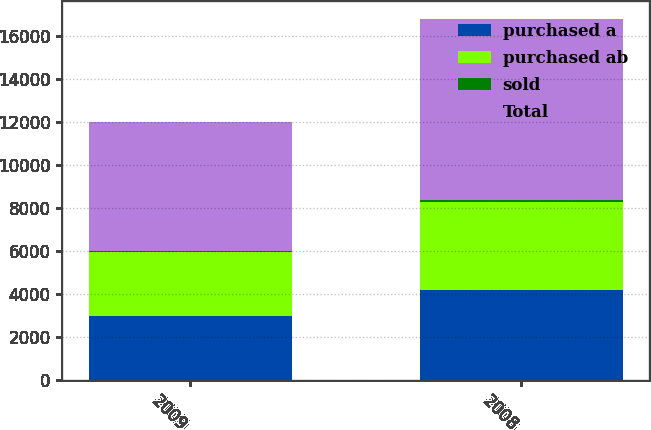Convert chart to OTSL. <chart><loc_0><loc_0><loc_500><loc_500><stacked_bar_chart><ecel><fcel>2009<fcel>2008<nl><fcel>purchased a<fcel>2997<fcel>4193<nl><fcel>purchased ab<fcel>2947<fcel>4102<nl><fcel>sold<fcel>49<fcel>92<nl><fcel>Total<fcel>5994<fcel>8388<nl></chart> 